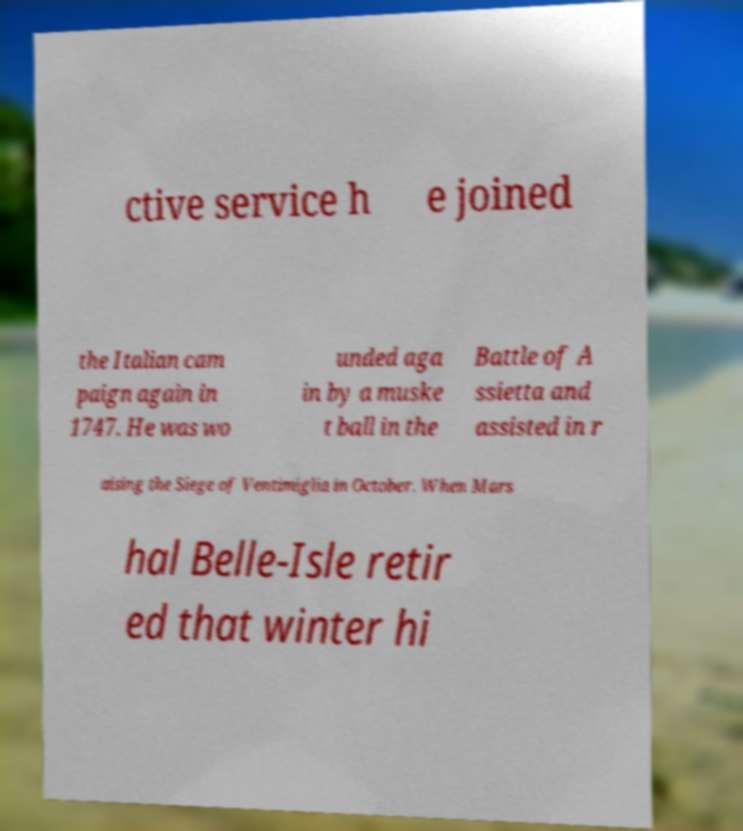I need the written content from this picture converted into text. Can you do that? ctive service h e joined the Italian cam paign again in 1747. He was wo unded aga in by a muske t ball in the Battle of A ssietta and assisted in r aising the Siege of Ventimiglia in October. When Mars hal Belle-Isle retir ed that winter hi 